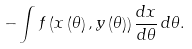<formula> <loc_0><loc_0><loc_500><loc_500>- \int f \left ( x \left ( \theta \right ) , y \left ( \theta \right ) \right ) \frac { d x } { d \theta } \, d \theta .</formula> 